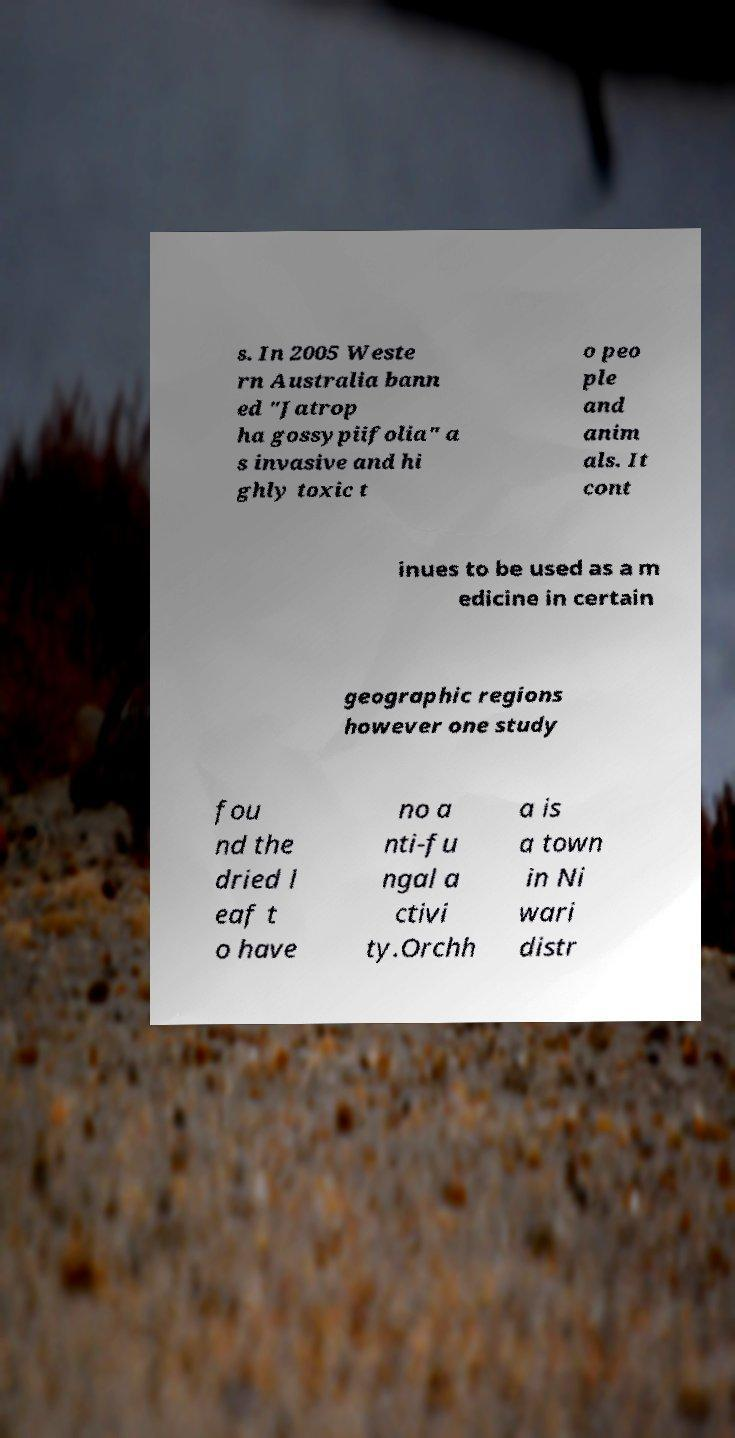Could you assist in decoding the text presented in this image and type it out clearly? s. In 2005 Weste rn Australia bann ed "Jatrop ha gossypiifolia" a s invasive and hi ghly toxic t o peo ple and anim als. It cont inues to be used as a m edicine in certain geographic regions however one study fou nd the dried l eaf t o have no a nti-fu ngal a ctivi ty.Orchh a is a town in Ni wari distr 